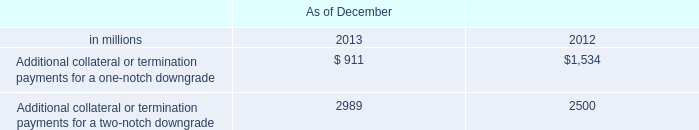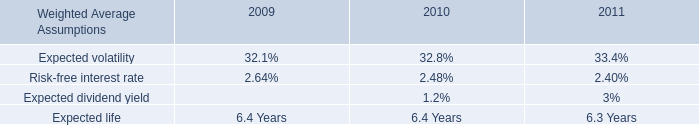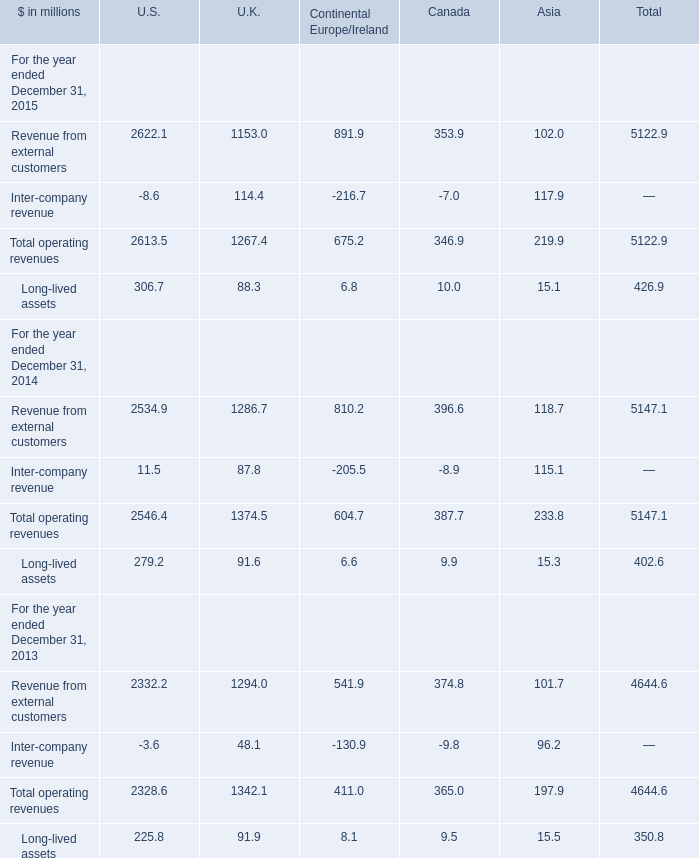In the year with lowest amount of Total operating revenues in terms of Canada, what's the increasing rate of Long-lived assets in terms of Canada? 
Computations: ((10.0 - 9.9) / 9.9)
Answer: 0.0101. 